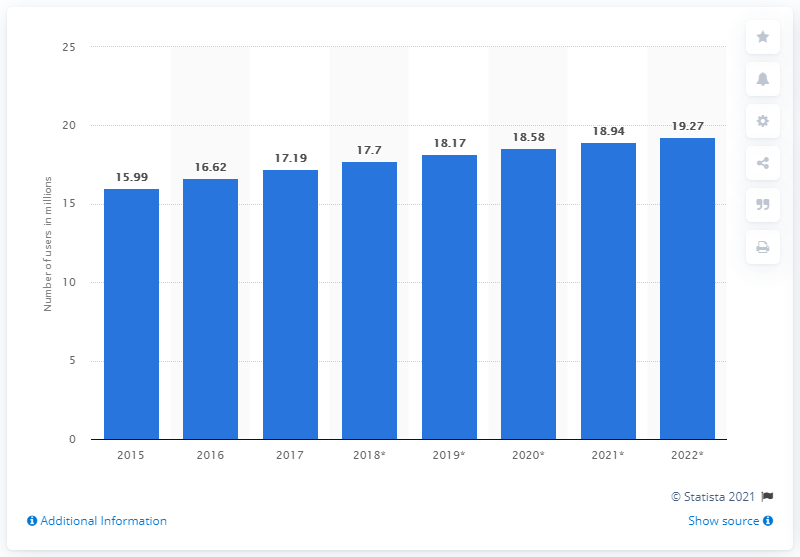List a handful of essential elements in this visual. In 2022, it is estimated that there will be approximately 19.27 million social network users in Australia. In 2017, there were approximately 17.19 million social network users in Australia. In 2017, there were approximately 17.19 million social network users in Australia. 